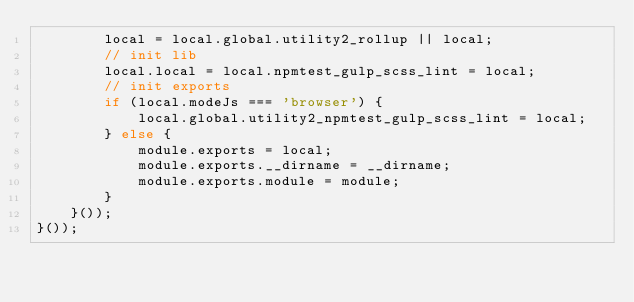Convert code to text. <code><loc_0><loc_0><loc_500><loc_500><_JavaScript_>        local = local.global.utility2_rollup || local;
        // init lib
        local.local = local.npmtest_gulp_scss_lint = local;
        // init exports
        if (local.modeJs === 'browser') {
            local.global.utility2_npmtest_gulp_scss_lint = local;
        } else {
            module.exports = local;
            module.exports.__dirname = __dirname;
            module.exports.module = module;
        }
    }());
}());
</code> 